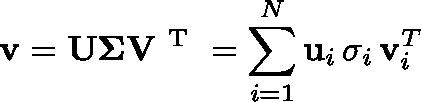<formula> <loc_0><loc_0><loc_500><loc_500>v = U \Sigma V ^ { T } = \sum _ { i = 1 } ^ { N } u _ { i } \, \sigma _ { i } \, v _ { i } ^ { T }</formula> 